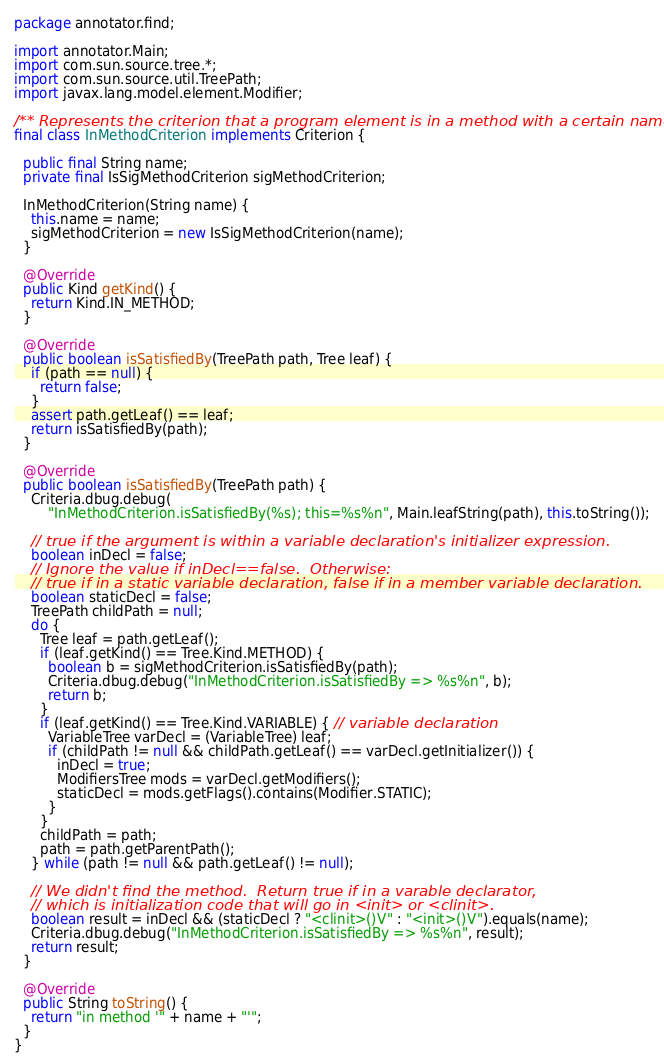Convert code to text. <code><loc_0><loc_0><loc_500><loc_500><_Java_>package annotator.find;

import annotator.Main;
import com.sun.source.tree.*;
import com.sun.source.util.TreePath;
import javax.lang.model.element.Modifier;

/** Represents the criterion that a program element is in a method with a certain name. */
final class InMethodCriterion implements Criterion {

  public final String name;
  private final IsSigMethodCriterion sigMethodCriterion;

  InMethodCriterion(String name) {
    this.name = name;
    sigMethodCriterion = new IsSigMethodCriterion(name);
  }

  @Override
  public Kind getKind() {
    return Kind.IN_METHOD;
  }

  @Override
  public boolean isSatisfiedBy(TreePath path, Tree leaf) {
    if (path == null) {
      return false;
    }
    assert path.getLeaf() == leaf;
    return isSatisfiedBy(path);
  }

  @Override
  public boolean isSatisfiedBy(TreePath path) {
    Criteria.dbug.debug(
        "InMethodCriterion.isSatisfiedBy(%s); this=%s%n", Main.leafString(path), this.toString());

    // true if the argument is within a variable declaration's initializer expression.
    boolean inDecl = false;
    // Ignore the value if inDecl==false.  Otherwise:
    // true if in a static variable declaration, false if in a member variable declaration.
    boolean staticDecl = false;
    TreePath childPath = null;
    do {
      Tree leaf = path.getLeaf();
      if (leaf.getKind() == Tree.Kind.METHOD) {
        boolean b = sigMethodCriterion.isSatisfiedBy(path);
        Criteria.dbug.debug("InMethodCriterion.isSatisfiedBy => %s%n", b);
        return b;
      }
      if (leaf.getKind() == Tree.Kind.VARIABLE) { // variable declaration
        VariableTree varDecl = (VariableTree) leaf;
        if (childPath != null && childPath.getLeaf() == varDecl.getInitializer()) {
          inDecl = true;
          ModifiersTree mods = varDecl.getModifiers();
          staticDecl = mods.getFlags().contains(Modifier.STATIC);
        }
      }
      childPath = path;
      path = path.getParentPath();
    } while (path != null && path.getLeaf() != null);

    // We didn't find the method.  Return true if in a varable declarator,
    // which is initialization code that will go in <init> or <clinit>.
    boolean result = inDecl && (staticDecl ? "<clinit>()V" : "<init>()V").equals(name);
    Criteria.dbug.debug("InMethodCriterion.isSatisfiedBy => %s%n", result);
    return result;
  }

  @Override
  public String toString() {
    return "in method '" + name + "'";
  }
}
</code> 